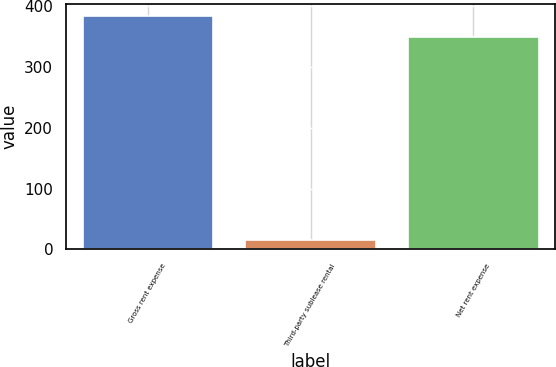Convert chart to OTSL. <chart><loc_0><loc_0><loc_500><loc_500><bar_chart><fcel>Gross rent expense<fcel>Third-party sublease rental<fcel>Net rent expense<nl><fcel>385<fcel>16.1<fcel>350<nl></chart> 